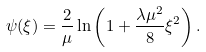<formula> <loc_0><loc_0><loc_500><loc_500>\psi ( \xi ) = \frac { 2 } { \mu } \ln \left ( 1 + \frac { \lambda \mu ^ { 2 } } { 8 } \xi ^ { 2 } \right ) .</formula> 